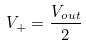Convert formula to latex. <formula><loc_0><loc_0><loc_500><loc_500>V _ { + } = \frac { V _ { o u t } } { 2 }</formula> 